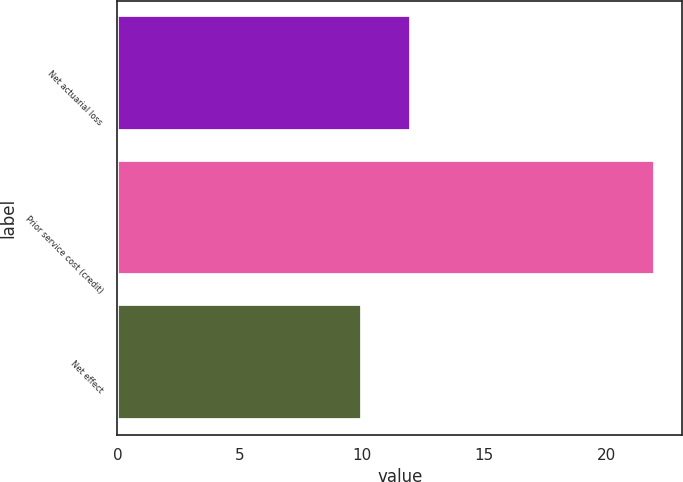<chart> <loc_0><loc_0><loc_500><loc_500><bar_chart><fcel>Net actuarial loss<fcel>Prior service cost (credit)<fcel>Net effect<nl><fcel>12<fcel>22<fcel>10<nl></chart> 